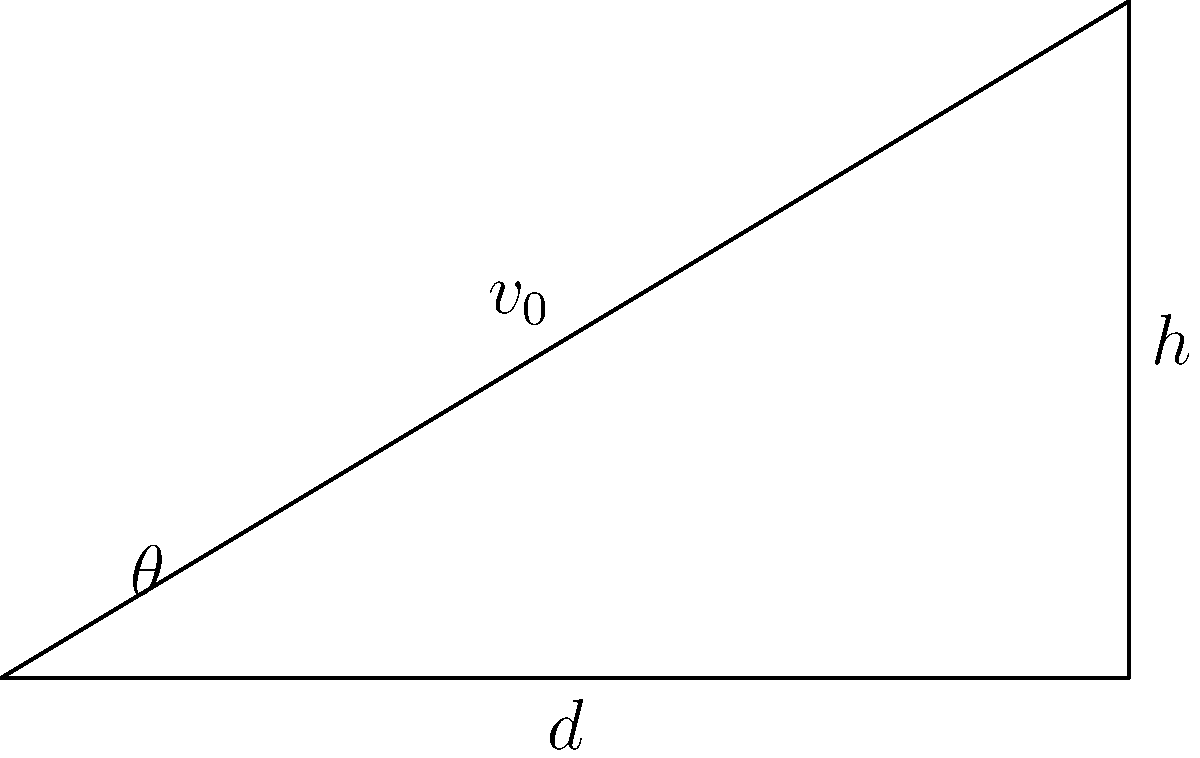As a project manager for a private space company, you're tasked with optimizing the launch angle for a new suborbital spacecraft. The spacecraft needs to reach a maximum height of 100 km and land 500 km downrange. Assuming no air resistance and uniform gravitational acceleration, determine the optimal launch angle $\theta$ (in degrees) using the given diagram and the equation $h = d \tan(\theta) - \frac{gd^2}{2v_0^2\cos^2(\theta)}$, where $h$ is the maximum height, $d$ is the downrange distance, $g$ is the gravitational acceleration (9.8 m/s²), and $v_0$ is the initial velocity. To solve this problem, we'll follow these steps:

1) We know that $h = 100$ km = 100,000 m and $d = 500$ km = 500,000 m.

2) The equation given is:
   $$h = d \tan(\theta) - \frac{gd^2}{2v_0^2\cos^2(\theta)}$$

3) For the optimal angle, the height will be at its maximum when $\frac{dh}{d\theta} = 0$. Taking the derivative and setting it to zero:
   $$\frac{dh}{d\theta} = d\sec^2(\theta) + \frac{gd^2}{v_0^2\cos^3(\theta)}\sin(\theta) = 0$$

4) Solving this equation leads to:
   $$\tan(\theta) = 1$$

5) This means the optimal angle is:
   $$\theta = \arctan(1) = 45°$$

6) We can verify this by plugging it back into the original equation:
   $$100,000 = 500,000 \tan(45°) - \frac{9.8(500,000)^2}{2v_0^2\cos^2(45°)}$$

7) Simplifying:
   $$100,000 = 500,000 - \frac{2.45 \times 10^{12}}{v_0^2}$$

8) Solving for $v_0$:
   $$v_0 = \sqrt{\frac{2.45 \times 10^{12}}{400,000}} \approx 2,475 \text{ m/s}$$

This initial velocity is reasonable for a suborbital spacecraft, confirming our solution.
Answer: 45° 